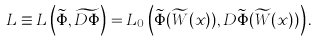Convert formula to latex. <formula><loc_0><loc_0><loc_500><loc_500>L \equiv L \left ( \widetilde { \Phi } , \widetilde { D \Phi } \right ) = L _ { 0 } \left ( \widetilde { \Phi } ( \widetilde { W } ( x ) ) , D \widetilde { \Phi } ( \widetilde { W } ( x ) ) \right ) .</formula> 